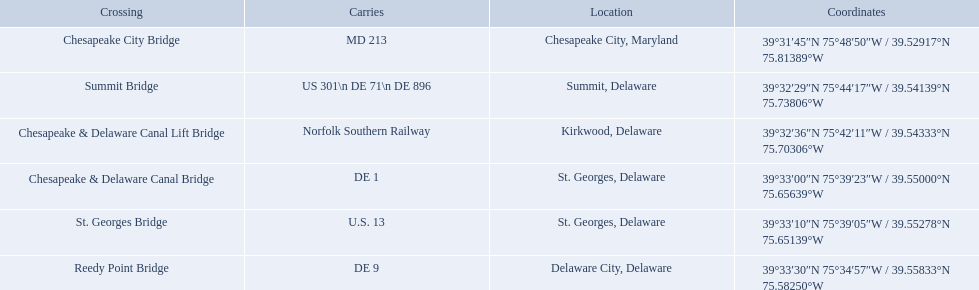Which bridges are in delaware? Summit Bridge, Chesapeake & Delaware Canal Lift Bridge, Chesapeake & Delaware Canal Bridge, St. Georges Bridge, Reedy Point Bridge. Which delaware bridge carries de 9? Reedy Point Bridge. What gets carried within the canal? MD 213, US 301\n DE 71\n DE 896, Norfolk Southern Railway, DE 1, U.S. 13, DE 9. Which of those carries de 9? DE 9. To what crossing does that entry correspond? Reedy Point Bridge. What are the carries of the crossing located in summit, delaware? US 301\n DE 71\n DE 896. Based on the answer in the previous question, what is the name of the crossing? Summit Bridge. What gets carried within the canal? MD 213, US 301\n DE 71\n DE 896, Norfolk Southern Railway, DE 1, U.S. 13, DE 9. Which of those carries de 9? DE 9. To what crossing does that entry correspond? Reedy Point Bridge. Which overpasses are located in delaware? Summit Bridge, Chesapeake & Delaware Canal Lift Bridge, Chesapeake & Delaware Canal Bridge, St. Georges Bridge, Reedy Point Bridge. Which delaware overpass supports de 9? Reedy Point Bridge. What is borne within the canal? MD 213, US 301\n DE 71\n DE 896, Norfolk Southern Railway, DE 1, U.S. 13, DE 9. Which of those bears de 9? DE 9. To which crossroads does that access correspond? Reedy Point Bridge. What is conveyed inside the canal? MD 213, US 301\n DE 71\n DE 896, Norfolk Southern Railway, DE 1, U.S. 13, DE 9. Which of those conveys de 9? DE 9. To what junction does that admission correspond? Reedy Point Bridge. What are the transporters of the crossing positioned in summit, delaware? US 301\n DE 71\n DE 896. Based on the reply in the earlier question, what is the designation of the crossing? Summit Bridge. Give me the full table as a dictionary. {'header': ['Crossing', 'Carries', 'Location', 'Coordinates'], 'rows': [['Chesapeake City Bridge', 'MD 213', 'Chesapeake City, Maryland', '39°31′45″N 75°48′50″W\ufeff / \ufeff39.52917°N 75.81389°W'], ['Summit Bridge', 'US 301\\n DE 71\\n DE 896', 'Summit, Delaware', '39°32′29″N 75°44′17″W\ufeff / \ufeff39.54139°N 75.73806°W'], ['Chesapeake & Delaware Canal Lift Bridge', 'Norfolk Southern Railway', 'Kirkwood, Delaware', '39°32′36″N 75°42′11″W\ufeff / \ufeff39.54333°N 75.70306°W'], ['Chesapeake & Delaware Canal Bridge', 'DE 1', 'St.\xa0Georges, Delaware', '39°33′00″N 75°39′23″W\ufeff / \ufeff39.55000°N 75.65639°W'], ['St.\xa0Georges Bridge', 'U.S.\xa013', 'St.\xa0Georges, Delaware', '39°33′10″N 75°39′05″W\ufeff / \ufeff39.55278°N 75.65139°W'], ['Reedy Point Bridge', 'DE\xa09', 'Delaware City, Delaware', '39°33′30″N 75°34′57″W\ufeff / \ufeff39.55833°N 75.58250°W']]} Which crossings are in delaware? Summit Bridge, Chesapeake & Delaware Canal Lift Bridge, Chesapeake & Delaware Canal Bridge, St. Georges Bridge, Reedy Point Bridge. Which delaware crossing holds de 9? Reedy Point Bridge. Which bridges exist? Chesapeake City Bridge, Summit Bridge, Chesapeake & Delaware Canal Lift Bridge, Chesapeake & Delaware Canal Bridge, St. Georges Bridge, Reedy Point Bridge. Which ones are located in delaware? Summit Bridge, Chesapeake & Delaware Canal Lift Bridge, Chesapeake & Delaware Canal Bridge, St. Georges Bridge, Reedy Point Bridge. Out of these, which one carries de 9? Reedy Point Bridge. What are the conveyors of the crossing found in summit, delaware? US 301\n DE 71\n DE 896. Based on the answer in the preceding question, what is the appellation of the crossing? Summit Bridge. What are the bridges located in delaware? Summit Bridge, Chesapeake & Delaware Canal Lift Bridge, Chesapeake & Delaware Canal Bridge, St. Georges Bridge, Reedy Point Bridge. Which bridge in delaware supports de 9? Reedy Point Bridge. What are the names of the crossings situated in summit, delaware? US 301\n DE 71\n DE 896. According to the previous response, what is the specific name of that crossing? Summit Bridge. In summit, delaware, which crossings are present? US 301\n DE 71\n DE 896. Based on the information given earlier, what is the crossing called? Summit Bridge. 